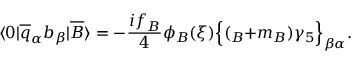<formula> <loc_0><loc_0><loc_500><loc_500>\langle 0 | \overline { q } _ { \alpha } b _ { \beta } | \overline { B } \rangle = - \frac { i f _ { B } } { 4 } \phi _ { B } ( \xi ) \left \{ ( \not { p } _ { B } + m _ { B } ) \gamma _ { 5 } \right \} _ { \beta \alpha } .</formula> 